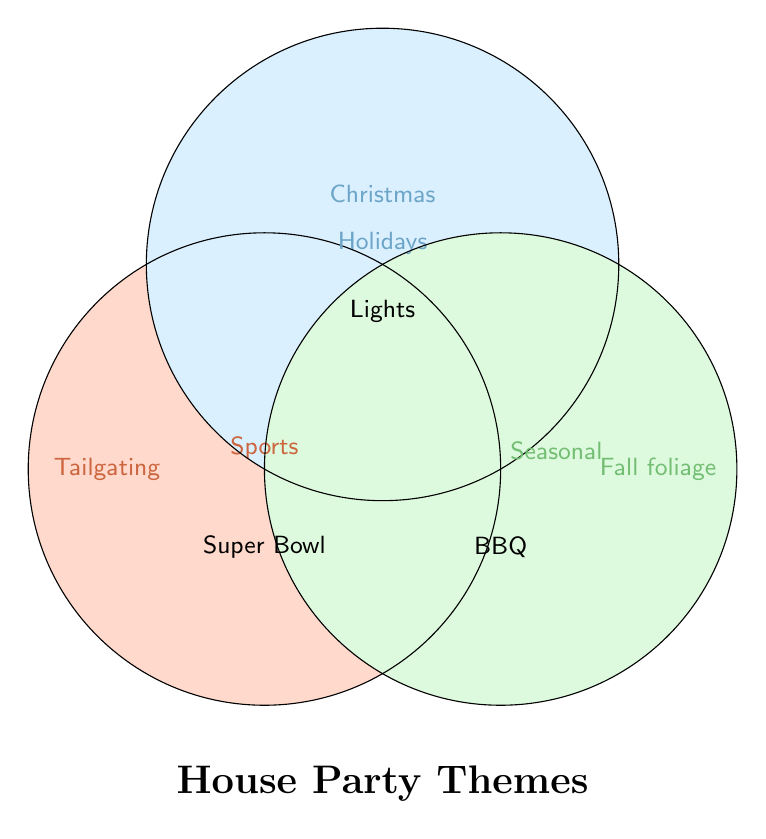What is the title of the Venn Diagram? The title is usually found prominently displayed above the figure. In this case, the phrase "House Party Themes" appears at the bottom of the diagram in the middle.
Answer: House Party Themes Which section is colored with something close to orange? Colors are used to signify different sections. The color close to orange represents the "Sports" category located on the left.
Answer: Sports What event is associated with the "Holiday" theme and is displayed separately? Each theme has several events listed. For the "Holiday" theme, the event shown separately, outside all circles, is "Christmas."
Answer: Christmas Where is the "BBQ" event located in the Venn Diagram? The BBQ event is placed in the middle right section of the diagram, within the intersection of the "Sports" and "Seasonal" circles.
Answer: Intersection of Sports and Seasonal What event is specifically tied to the "Sports" theme and positioned on the lower left part of the circle? The "Sports" circle contains multiple events. The event on the lower left within the "Sports" circle is "Super Bowl."
Answer: Super Bowl Which themes intersect to highlight "Lights"? The "Lights" event is placed at an intersection, showing it belongs to multiple themes. It is at the common area of both "Holiday" and "Seasonal" themes.
Answer: Holidays and Seasonal Identify an event that belongs exclusively to the "Seasonal" category based on the diagram. Events belonging exclusively to a theme are usually mentioned only within that particular circle. For the "Seasonal" category, "Fall foliage" is placed separately and exclusively.
Answer: Fall foliage 